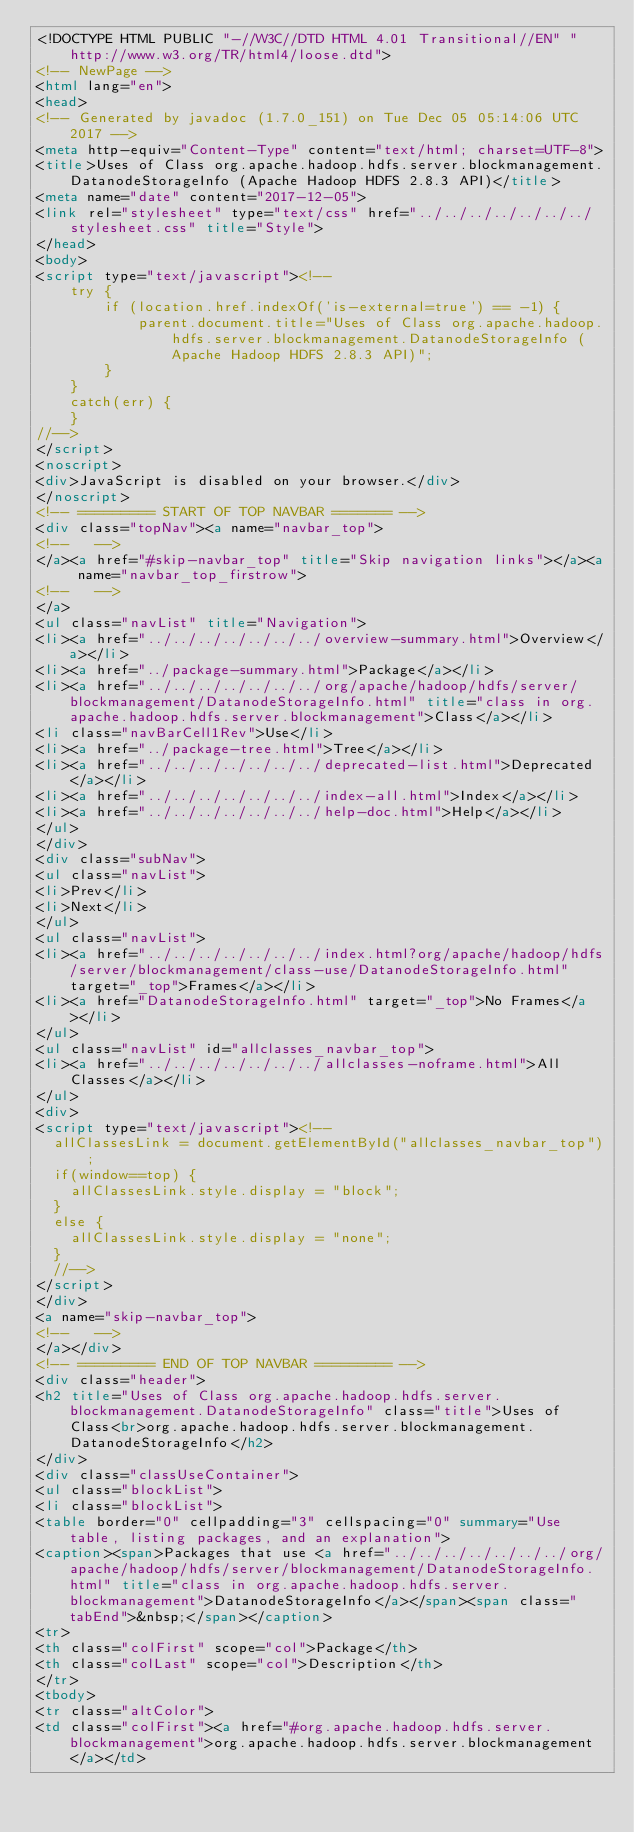Convert code to text. <code><loc_0><loc_0><loc_500><loc_500><_HTML_><!DOCTYPE HTML PUBLIC "-//W3C//DTD HTML 4.01 Transitional//EN" "http://www.w3.org/TR/html4/loose.dtd">
<!-- NewPage -->
<html lang="en">
<head>
<!-- Generated by javadoc (1.7.0_151) on Tue Dec 05 05:14:06 UTC 2017 -->
<meta http-equiv="Content-Type" content="text/html; charset=UTF-8">
<title>Uses of Class org.apache.hadoop.hdfs.server.blockmanagement.DatanodeStorageInfo (Apache Hadoop HDFS 2.8.3 API)</title>
<meta name="date" content="2017-12-05">
<link rel="stylesheet" type="text/css" href="../../../../../../../stylesheet.css" title="Style">
</head>
<body>
<script type="text/javascript"><!--
    try {
        if (location.href.indexOf('is-external=true') == -1) {
            parent.document.title="Uses of Class org.apache.hadoop.hdfs.server.blockmanagement.DatanodeStorageInfo (Apache Hadoop HDFS 2.8.3 API)";
        }
    }
    catch(err) {
    }
//-->
</script>
<noscript>
<div>JavaScript is disabled on your browser.</div>
</noscript>
<!-- ========= START OF TOP NAVBAR ======= -->
<div class="topNav"><a name="navbar_top">
<!--   -->
</a><a href="#skip-navbar_top" title="Skip navigation links"></a><a name="navbar_top_firstrow">
<!--   -->
</a>
<ul class="navList" title="Navigation">
<li><a href="../../../../../../../overview-summary.html">Overview</a></li>
<li><a href="../package-summary.html">Package</a></li>
<li><a href="../../../../../../../org/apache/hadoop/hdfs/server/blockmanagement/DatanodeStorageInfo.html" title="class in org.apache.hadoop.hdfs.server.blockmanagement">Class</a></li>
<li class="navBarCell1Rev">Use</li>
<li><a href="../package-tree.html">Tree</a></li>
<li><a href="../../../../../../../deprecated-list.html">Deprecated</a></li>
<li><a href="../../../../../../../index-all.html">Index</a></li>
<li><a href="../../../../../../../help-doc.html">Help</a></li>
</ul>
</div>
<div class="subNav">
<ul class="navList">
<li>Prev</li>
<li>Next</li>
</ul>
<ul class="navList">
<li><a href="../../../../../../../index.html?org/apache/hadoop/hdfs/server/blockmanagement/class-use/DatanodeStorageInfo.html" target="_top">Frames</a></li>
<li><a href="DatanodeStorageInfo.html" target="_top">No Frames</a></li>
</ul>
<ul class="navList" id="allclasses_navbar_top">
<li><a href="../../../../../../../allclasses-noframe.html">All Classes</a></li>
</ul>
<div>
<script type="text/javascript"><!--
  allClassesLink = document.getElementById("allclasses_navbar_top");
  if(window==top) {
    allClassesLink.style.display = "block";
  }
  else {
    allClassesLink.style.display = "none";
  }
  //-->
</script>
</div>
<a name="skip-navbar_top">
<!--   -->
</a></div>
<!-- ========= END OF TOP NAVBAR ========= -->
<div class="header">
<h2 title="Uses of Class org.apache.hadoop.hdfs.server.blockmanagement.DatanodeStorageInfo" class="title">Uses of Class<br>org.apache.hadoop.hdfs.server.blockmanagement.DatanodeStorageInfo</h2>
</div>
<div class="classUseContainer">
<ul class="blockList">
<li class="blockList">
<table border="0" cellpadding="3" cellspacing="0" summary="Use table, listing packages, and an explanation">
<caption><span>Packages that use <a href="../../../../../../../org/apache/hadoop/hdfs/server/blockmanagement/DatanodeStorageInfo.html" title="class in org.apache.hadoop.hdfs.server.blockmanagement">DatanodeStorageInfo</a></span><span class="tabEnd">&nbsp;</span></caption>
<tr>
<th class="colFirst" scope="col">Package</th>
<th class="colLast" scope="col">Description</th>
</tr>
<tbody>
<tr class="altColor">
<td class="colFirst"><a href="#org.apache.hadoop.hdfs.server.blockmanagement">org.apache.hadoop.hdfs.server.blockmanagement</a></td></code> 